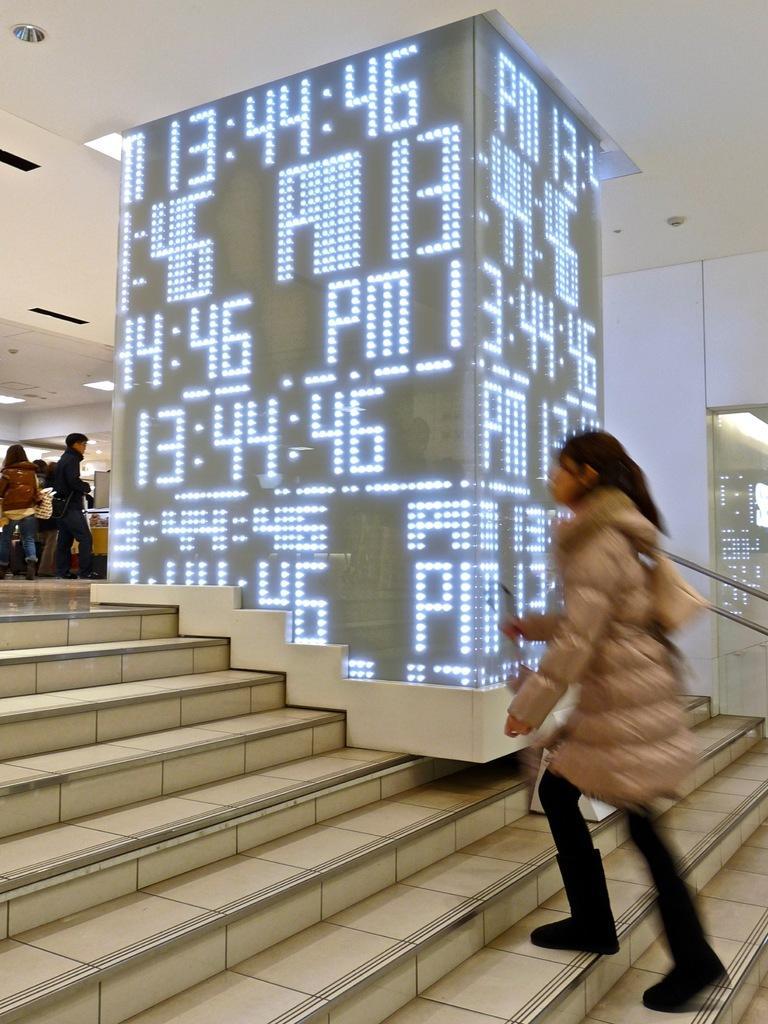Can you describe this image briefly? In this picture, we can see a few people, and a person on the stairs, we can see stairs, railing, screen, wall, roof with some lights and some objects attached to it. 